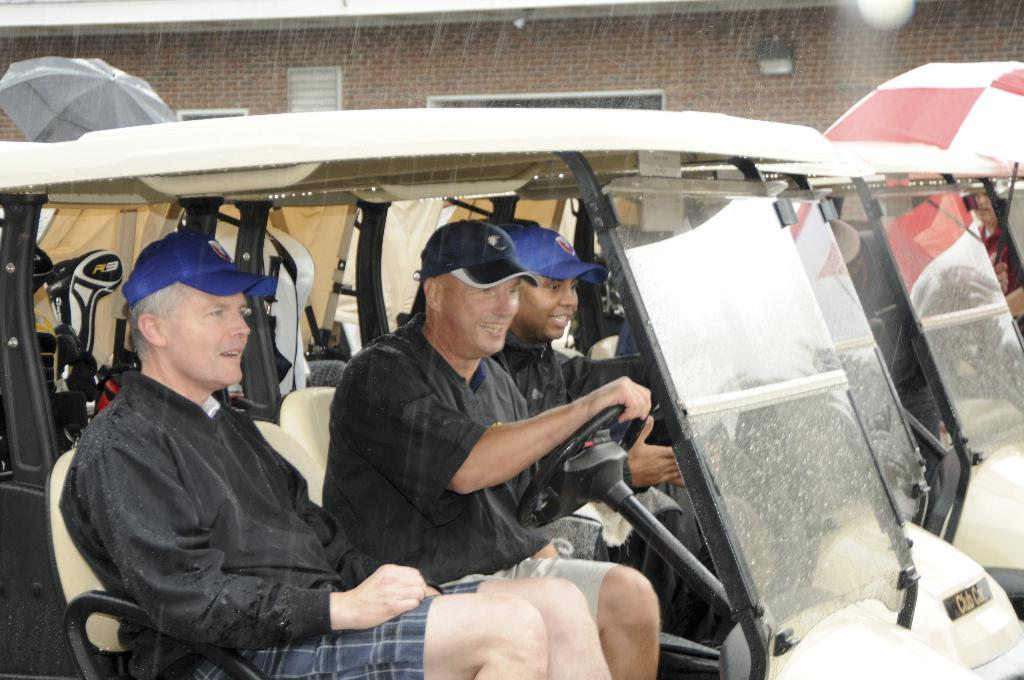What is happening in the image involving people? There are people in a vehicle in the image. What objects are being used to protect against the rain? Umbrellas are visible in the image. What weather condition is occurring in the image? Rain is present in the image. What can be seen in the distance behind the vehicle? There is a building in the background of the image. What type of knowledge is being produced by the people in the image? There is no indication in the image that the people are producing knowledge; they are in a vehicle during rain. What is the name of the building in the background of the image? The name of the building is not mentioned in the image, only its presence is noted. 